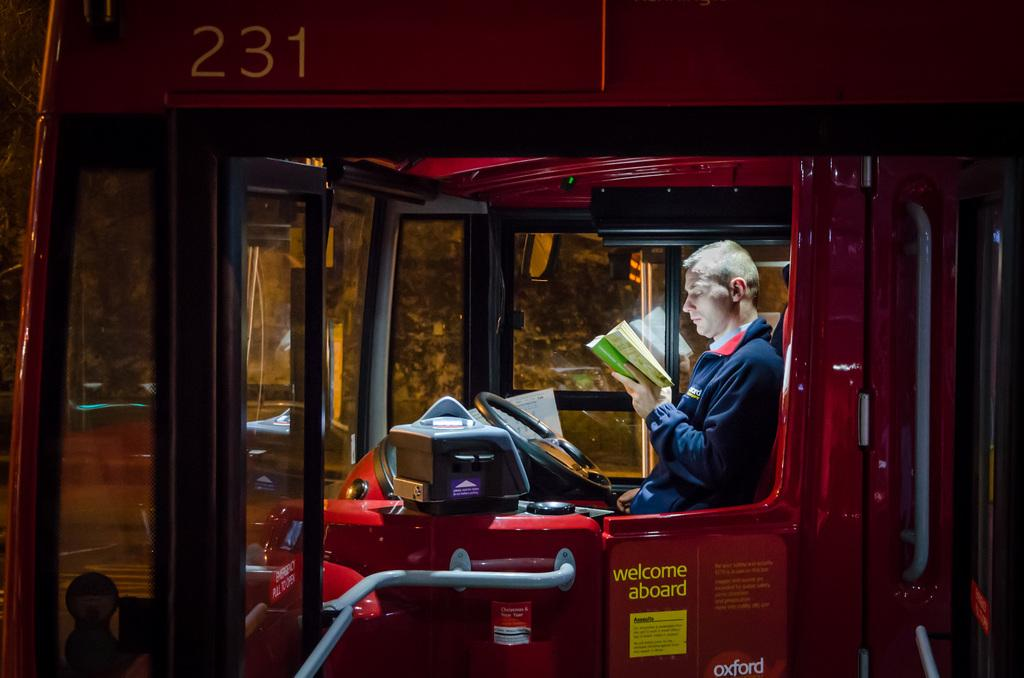What is the person in the image doing? There is a person sitting in the truck in the image. What can be seen in the background of the image? There is a tree visible in the background of the image. How many children are playing with the sock on the person's chin in the image? There are no children, sock, or chin present in the image. 